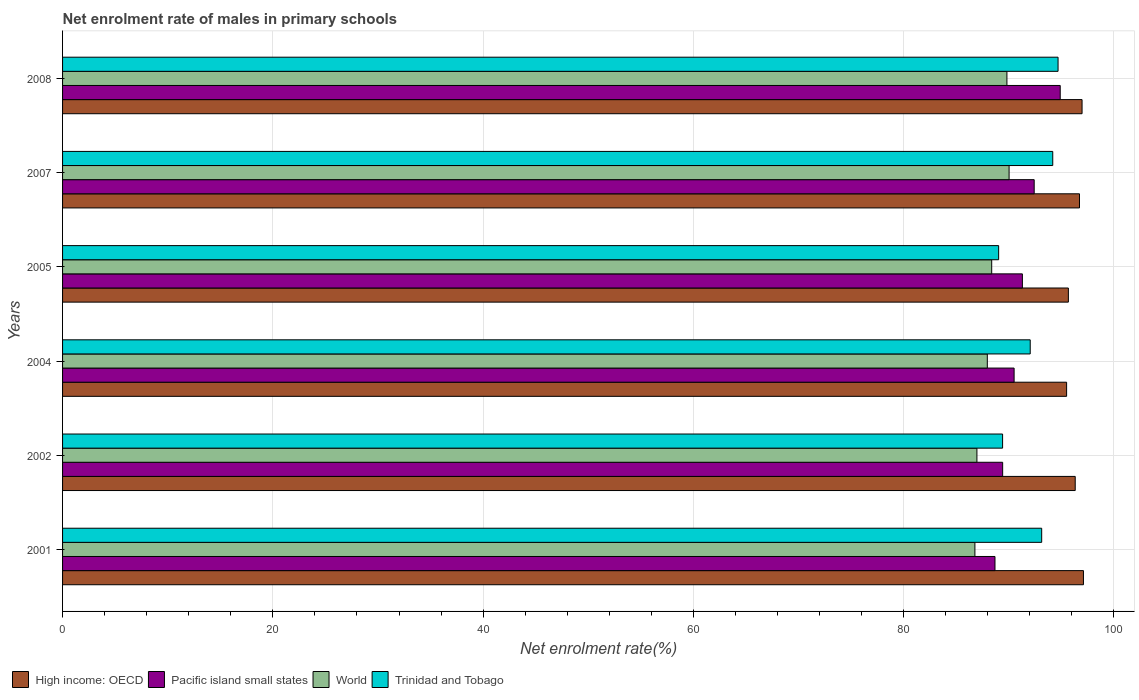Are the number of bars per tick equal to the number of legend labels?
Offer a terse response. Yes. Are the number of bars on each tick of the Y-axis equal?
Keep it short and to the point. Yes. How many bars are there on the 3rd tick from the top?
Offer a terse response. 4. How many bars are there on the 3rd tick from the bottom?
Provide a succinct answer. 4. In how many cases, is the number of bars for a given year not equal to the number of legend labels?
Your answer should be very brief. 0. What is the net enrolment rate of males in primary schools in High income: OECD in 2004?
Your response must be concise. 95.5. Across all years, what is the maximum net enrolment rate of males in primary schools in Pacific island small states?
Provide a short and direct response. 94.89. Across all years, what is the minimum net enrolment rate of males in primary schools in High income: OECD?
Provide a short and direct response. 95.5. In which year was the net enrolment rate of males in primary schools in High income: OECD maximum?
Keep it short and to the point. 2001. What is the total net enrolment rate of males in primary schools in High income: OECD in the graph?
Give a very brief answer. 578.27. What is the difference between the net enrolment rate of males in primary schools in Trinidad and Tobago in 2001 and that in 2004?
Offer a terse response. 1.09. What is the difference between the net enrolment rate of males in primary schools in Pacific island small states in 2008 and the net enrolment rate of males in primary schools in World in 2001?
Your answer should be compact. 8.11. What is the average net enrolment rate of males in primary schools in World per year?
Offer a very short reply. 88.32. In the year 2005, what is the difference between the net enrolment rate of males in primary schools in Trinidad and Tobago and net enrolment rate of males in primary schools in World?
Your response must be concise. 0.66. In how many years, is the net enrolment rate of males in primary schools in World greater than 96 %?
Your response must be concise. 0. What is the ratio of the net enrolment rate of males in primary schools in Pacific island small states in 2002 to that in 2007?
Provide a succinct answer. 0.97. Is the difference between the net enrolment rate of males in primary schools in Trinidad and Tobago in 2001 and 2004 greater than the difference between the net enrolment rate of males in primary schools in World in 2001 and 2004?
Provide a short and direct response. Yes. What is the difference between the highest and the second highest net enrolment rate of males in primary schools in High income: OECD?
Keep it short and to the point. 0.13. What is the difference between the highest and the lowest net enrolment rate of males in primary schools in World?
Provide a succinct answer. 3.25. Is the sum of the net enrolment rate of males in primary schools in Trinidad and Tobago in 2007 and 2008 greater than the maximum net enrolment rate of males in primary schools in High income: OECD across all years?
Offer a very short reply. Yes. Is it the case that in every year, the sum of the net enrolment rate of males in primary schools in Trinidad and Tobago and net enrolment rate of males in primary schools in Pacific island small states is greater than the sum of net enrolment rate of males in primary schools in High income: OECD and net enrolment rate of males in primary schools in World?
Offer a very short reply. Yes. What does the 1st bar from the top in 2007 represents?
Your response must be concise. Trinidad and Tobago. What does the 3rd bar from the bottom in 2004 represents?
Keep it short and to the point. World. Is it the case that in every year, the sum of the net enrolment rate of males in primary schools in World and net enrolment rate of males in primary schools in Trinidad and Tobago is greater than the net enrolment rate of males in primary schools in Pacific island small states?
Offer a terse response. Yes. How many bars are there?
Give a very brief answer. 24. Are all the bars in the graph horizontal?
Provide a short and direct response. Yes. How many years are there in the graph?
Your answer should be very brief. 6. Are the values on the major ticks of X-axis written in scientific E-notation?
Provide a succinct answer. No. Does the graph contain grids?
Your response must be concise. Yes. How are the legend labels stacked?
Provide a succinct answer. Horizontal. What is the title of the graph?
Ensure brevity in your answer.  Net enrolment rate of males in primary schools. Does "Malta" appear as one of the legend labels in the graph?
Give a very brief answer. No. What is the label or title of the X-axis?
Offer a very short reply. Net enrolment rate(%). What is the Net enrolment rate(%) of High income: OECD in 2001?
Offer a terse response. 97.1. What is the Net enrolment rate(%) in Pacific island small states in 2001?
Provide a short and direct response. 88.69. What is the Net enrolment rate(%) in World in 2001?
Your answer should be compact. 86.78. What is the Net enrolment rate(%) of Trinidad and Tobago in 2001?
Your answer should be compact. 93.13. What is the Net enrolment rate(%) of High income: OECD in 2002?
Offer a very short reply. 96.32. What is the Net enrolment rate(%) in Pacific island small states in 2002?
Your answer should be compact. 89.41. What is the Net enrolment rate(%) of World in 2002?
Your answer should be very brief. 86.97. What is the Net enrolment rate(%) in Trinidad and Tobago in 2002?
Ensure brevity in your answer.  89.41. What is the Net enrolment rate(%) in High income: OECD in 2004?
Your response must be concise. 95.5. What is the Net enrolment rate(%) of Pacific island small states in 2004?
Ensure brevity in your answer.  90.5. What is the Net enrolment rate(%) of World in 2004?
Provide a short and direct response. 87.96. What is the Net enrolment rate(%) of Trinidad and Tobago in 2004?
Ensure brevity in your answer.  92.04. What is the Net enrolment rate(%) in High income: OECD in 2005?
Give a very brief answer. 95.67. What is the Net enrolment rate(%) of Pacific island small states in 2005?
Your response must be concise. 91.29. What is the Net enrolment rate(%) in World in 2005?
Make the answer very short. 88.37. What is the Net enrolment rate(%) of Trinidad and Tobago in 2005?
Your answer should be very brief. 89.03. What is the Net enrolment rate(%) in High income: OECD in 2007?
Make the answer very short. 96.72. What is the Net enrolment rate(%) of Pacific island small states in 2007?
Keep it short and to the point. 92.42. What is the Net enrolment rate(%) of World in 2007?
Provide a succinct answer. 90.03. What is the Net enrolment rate(%) of Trinidad and Tobago in 2007?
Offer a terse response. 94.18. What is the Net enrolment rate(%) of High income: OECD in 2008?
Provide a short and direct response. 96.97. What is the Net enrolment rate(%) of Pacific island small states in 2008?
Your answer should be very brief. 94.89. What is the Net enrolment rate(%) in World in 2008?
Offer a terse response. 89.82. What is the Net enrolment rate(%) of Trinidad and Tobago in 2008?
Your answer should be compact. 94.68. Across all years, what is the maximum Net enrolment rate(%) of High income: OECD?
Make the answer very short. 97.1. Across all years, what is the maximum Net enrolment rate(%) in Pacific island small states?
Offer a very short reply. 94.89. Across all years, what is the maximum Net enrolment rate(%) in World?
Keep it short and to the point. 90.03. Across all years, what is the maximum Net enrolment rate(%) of Trinidad and Tobago?
Make the answer very short. 94.68. Across all years, what is the minimum Net enrolment rate(%) of High income: OECD?
Offer a terse response. 95.5. Across all years, what is the minimum Net enrolment rate(%) of Pacific island small states?
Offer a terse response. 88.69. Across all years, what is the minimum Net enrolment rate(%) in World?
Offer a terse response. 86.78. Across all years, what is the minimum Net enrolment rate(%) of Trinidad and Tobago?
Ensure brevity in your answer.  89.03. What is the total Net enrolment rate(%) in High income: OECD in the graph?
Your answer should be very brief. 578.27. What is the total Net enrolment rate(%) of Pacific island small states in the graph?
Keep it short and to the point. 547.2. What is the total Net enrolment rate(%) in World in the graph?
Your answer should be very brief. 529.92. What is the total Net enrolment rate(%) of Trinidad and Tobago in the graph?
Your response must be concise. 552.47. What is the difference between the Net enrolment rate(%) of High income: OECD in 2001 and that in 2002?
Make the answer very short. 0.78. What is the difference between the Net enrolment rate(%) in Pacific island small states in 2001 and that in 2002?
Provide a succinct answer. -0.73. What is the difference between the Net enrolment rate(%) in World in 2001 and that in 2002?
Provide a short and direct response. -0.19. What is the difference between the Net enrolment rate(%) in Trinidad and Tobago in 2001 and that in 2002?
Your answer should be compact. 3.72. What is the difference between the Net enrolment rate(%) of High income: OECD in 2001 and that in 2004?
Your answer should be very brief. 1.6. What is the difference between the Net enrolment rate(%) of Pacific island small states in 2001 and that in 2004?
Your response must be concise. -1.82. What is the difference between the Net enrolment rate(%) of World in 2001 and that in 2004?
Your answer should be compact. -1.18. What is the difference between the Net enrolment rate(%) in Trinidad and Tobago in 2001 and that in 2004?
Give a very brief answer. 1.09. What is the difference between the Net enrolment rate(%) in High income: OECD in 2001 and that in 2005?
Provide a short and direct response. 1.43. What is the difference between the Net enrolment rate(%) of Pacific island small states in 2001 and that in 2005?
Provide a short and direct response. -2.61. What is the difference between the Net enrolment rate(%) in World in 2001 and that in 2005?
Offer a terse response. -1.6. What is the difference between the Net enrolment rate(%) of Trinidad and Tobago in 2001 and that in 2005?
Your answer should be very brief. 4.09. What is the difference between the Net enrolment rate(%) in High income: OECD in 2001 and that in 2007?
Provide a short and direct response. 0.38. What is the difference between the Net enrolment rate(%) of Pacific island small states in 2001 and that in 2007?
Your answer should be very brief. -3.73. What is the difference between the Net enrolment rate(%) of World in 2001 and that in 2007?
Ensure brevity in your answer.  -3.25. What is the difference between the Net enrolment rate(%) in Trinidad and Tobago in 2001 and that in 2007?
Provide a succinct answer. -1.05. What is the difference between the Net enrolment rate(%) in High income: OECD in 2001 and that in 2008?
Your answer should be very brief. 0.13. What is the difference between the Net enrolment rate(%) in Pacific island small states in 2001 and that in 2008?
Your answer should be very brief. -6.2. What is the difference between the Net enrolment rate(%) in World in 2001 and that in 2008?
Offer a very short reply. -3.04. What is the difference between the Net enrolment rate(%) of Trinidad and Tobago in 2001 and that in 2008?
Your response must be concise. -1.56. What is the difference between the Net enrolment rate(%) of High income: OECD in 2002 and that in 2004?
Your answer should be very brief. 0.82. What is the difference between the Net enrolment rate(%) in Pacific island small states in 2002 and that in 2004?
Give a very brief answer. -1.09. What is the difference between the Net enrolment rate(%) in World in 2002 and that in 2004?
Provide a succinct answer. -0.99. What is the difference between the Net enrolment rate(%) of Trinidad and Tobago in 2002 and that in 2004?
Provide a short and direct response. -2.63. What is the difference between the Net enrolment rate(%) of High income: OECD in 2002 and that in 2005?
Provide a succinct answer. 0.65. What is the difference between the Net enrolment rate(%) of Pacific island small states in 2002 and that in 2005?
Offer a very short reply. -1.88. What is the difference between the Net enrolment rate(%) in World in 2002 and that in 2005?
Your answer should be very brief. -1.41. What is the difference between the Net enrolment rate(%) in Trinidad and Tobago in 2002 and that in 2005?
Your response must be concise. 0.38. What is the difference between the Net enrolment rate(%) in High income: OECD in 2002 and that in 2007?
Give a very brief answer. -0.41. What is the difference between the Net enrolment rate(%) in Pacific island small states in 2002 and that in 2007?
Keep it short and to the point. -3. What is the difference between the Net enrolment rate(%) of World in 2002 and that in 2007?
Keep it short and to the point. -3.06. What is the difference between the Net enrolment rate(%) of Trinidad and Tobago in 2002 and that in 2007?
Make the answer very short. -4.77. What is the difference between the Net enrolment rate(%) in High income: OECD in 2002 and that in 2008?
Ensure brevity in your answer.  -0.65. What is the difference between the Net enrolment rate(%) of Pacific island small states in 2002 and that in 2008?
Provide a succinct answer. -5.48. What is the difference between the Net enrolment rate(%) in World in 2002 and that in 2008?
Offer a terse response. -2.85. What is the difference between the Net enrolment rate(%) in Trinidad and Tobago in 2002 and that in 2008?
Ensure brevity in your answer.  -5.27. What is the difference between the Net enrolment rate(%) of High income: OECD in 2004 and that in 2005?
Provide a short and direct response. -0.17. What is the difference between the Net enrolment rate(%) in Pacific island small states in 2004 and that in 2005?
Make the answer very short. -0.79. What is the difference between the Net enrolment rate(%) in World in 2004 and that in 2005?
Offer a very short reply. -0.42. What is the difference between the Net enrolment rate(%) in Trinidad and Tobago in 2004 and that in 2005?
Make the answer very short. 3. What is the difference between the Net enrolment rate(%) of High income: OECD in 2004 and that in 2007?
Give a very brief answer. -1.22. What is the difference between the Net enrolment rate(%) in Pacific island small states in 2004 and that in 2007?
Your answer should be compact. -1.91. What is the difference between the Net enrolment rate(%) in World in 2004 and that in 2007?
Provide a short and direct response. -2.07. What is the difference between the Net enrolment rate(%) of Trinidad and Tobago in 2004 and that in 2007?
Offer a terse response. -2.14. What is the difference between the Net enrolment rate(%) in High income: OECD in 2004 and that in 2008?
Your response must be concise. -1.47. What is the difference between the Net enrolment rate(%) of Pacific island small states in 2004 and that in 2008?
Offer a very short reply. -4.39. What is the difference between the Net enrolment rate(%) in World in 2004 and that in 2008?
Ensure brevity in your answer.  -1.86. What is the difference between the Net enrolment rate(%) in Trinidad and Tobago in 2004 and that in 2008?
Provide a succinct answer. -2.65. What is the difference between the Net enrolment rate(%) of High income: OECD in 2005 and that in 2007?
Your answer should be very brief. -1.06. What is the difference between the Net enrolment rate(%) of Pacific island small states in 2005 and that in 2007?
Give a very brief answer. -1.12. What is the difference between the Net enrolment rate(%) in World in 2005 and that in 2007?
Make the answer very short. -1.65. What is the difference between the Net enrolment rate(%) in Trinidad and Tobago in 2005 and that in 2007?
Provide a succinct answer. -5.15. What is the difference between the Net enrolment rate(%) of High income: OECD in 2005 and that in 2008?
Give a very brief answer. -1.3. What is the difference between the Net enrolment rate(%) in Pacific island small states in 2005 and that in 2008?
Your answer should be very brief. -3.6. What is the difference between the Net enrolment rate(%) of World in 2005 and that in 2008?
Your response must be concise. -1.45. What is the difference between the Net enrolment rate(%) of Trinidad and Tobago in 2005 and that in 2008?
Your answer should be very brief. -5.65. What is the difference between the Net enrolment rate(%) in High income: OECD in 2007 and that in 2008?
Make the answer very short. -0.24. What is the difference between the Net enrolment rate(%) in Pacific island small states in 2007 and that in 2008?
Ensure brevity in your answer.  -2.48. What is the difference between the Net enrolment rate(%) in World in 2007 and that in 2008?
Keep it short and to the point. 0.21. What is the difference between the Net enrolment rate(%) in Trinidad and Tobago in 2007 and that in 2008?
Offer a very short reply. -0.51. What is the difference between the Net enrolment rate(%) of High income: OECD in 2001 and the Net enrolment rate(%) of Pacific island small states in 2002?
Provide a short and direct response. 7.68. What is the difference between the Net enrolment rate(%) in High income: OECD in 2001 and the Net enrolment rate(%) in World in 2002?
Ensure brevity in your answer.  10.13. What is the difference between the Net enrolment rate(%) of High income: OECD in 2001 and the Net enrolment rate(%) of Trinidad and Tobago in 2002?
Your answer should be very brief. 7.69. What is the difference between the Net enrolment rate(%) in Pacific island small states in 2001 and the Net enrolment rate(%) in World in 2002?
Give a very brief answer. 1.72. What is the difference between the Net enrolment rate(%) of Pacific island small states in 2001 and the Net enrolment rate(%) of Trinidad and Tobago in 2002?
Give a very brief answer. -0.72. What is the difference between the Net enrolment rate(%) of World in 2001 and the Net enrolment rate(%) of Trinidad and Tobago in 2002?
Your answer should be compact. -2.63. What is the difference between the Net enrolment rate(%) of High income: OECD in 2001 and the Net enrolment rate(%) of Pacific island small states in 2004?
Keep it short and to the point. 6.6. What is the difference between the Net enrolment rate(%) in High income: OECD in 2001 and the Net enrolment rate(%) in World in 2004?
Give a very brief answer. 9.14. What is the difference between the Net enrolment rate(%) of High income: OECD in 2001 and the Net enrolment rate(%) of Trinidad and Tobago in 2004?
Offer a terse response. 5.06. What is the difference between the Net enrolment rate(%) in Pacific island small states in 2001 and the Net enrolment rate(%) in World in 2004?
Your response must be concise. 0.73. What is the difference between the Net enrolment rate(%) of Pacific island small states in 2001 and the Net enrolment rate(%) of Trinidad and Tobago in 2004?
Your answer should be very brief. -3.35. What is the difference between the Net enrolment rate(%) in World in 2001 and the Net enrolment rate(%) in Trinidad and Tobago in 2004?
Give a very brief answer. -5.26. What is the difference between the Net enrolment rate(%) of High income: OECD in 2001 and the Net enrolment rate(%) of Pacific island small states in 2005?
Your answer should be compact. 5.81. What is the difference between the Net enrolment rate(%) in High income: OECD in 2001 and the Net enrolment rate(%) in World in 2005?
Provide a succinct answer. 8.73. What is the difference between the Net enrolment rate(%) in High income: OECD in 2001 and the Net enrolment rate(%) in Trinidad and Tobago in 2005?
Give a very brief answer. 8.07. What is the difference between the Net enrolment rate(%) in Pacific island small states in 2001 and the Net enrolment rate(%) in World in 2005?
Offer a very short reply. 0.31. What is the difference between the Net enrolment rate(%) in Pacific island small states in 2001 and the Net enrolment rate(%) in Trinidad and Tobago in 2005?
Offer a terse response. -0.35. What is the difference between the Net enrolment rate(%) of World in 2001 and the Net enrolment rate(%) of Trinidad and Tobago in 2005?
Offer a very short reply. -2.26. What is the difference between the Net enrolment rate(%) in High income: OECD in 2001 and the Net enrolment rate(%) in Pacific island small states in 2007?
Provide a succinct answer. 4.68. What is the difference between the Net enrolment rate(%) of High income: OECD in 2001 and the Net enrolment rate(%) of World in 2007?
Provide a short and direct response. 7.07. What is the difference between the Net enrolment rate(%) in High income: OECD in 2001 and the Net enrolment rate(%) in Trinidad and Tobago in 2007?
Provide a succinct answer. 2.92. What is the difference between the Net enrolment rate(%) of Pacific island small states in 2001 and the Net enrolment rate(%) of World in 2007?
Keep it short and to the point. -1.34. What is the difference between the Net enrolment rate(%) in Pacific island small states in 2001 and the Net enrolment rate(%) in Trinidad and Tobago in 2007?
Your response must be concise. -5.49. What is the difference between the Net enrolment rate(%) of World in 2001 and the Net enrolment rate(%) of Trinidad and Tobago in 2007?
Make the answer very short. -7.4. What is the difference between the Net enrolment rate(%) in High income: OECD in 2001 and the Net enrolment rate(%) in Pacific island small states in 2008?
Give a very brief answer. 2.21. What is the difference between the Net enrolment rate(%) of High income: OECD in 2001 and the Net enrolment rate(%) of World in 2008?
Make the answer very short. 7.28. What is the difference between the Net enrolment rate(%) of High income: OECD in 2001 and the Net enrolment rate(%) of Trinidad and Tobago in 2008?
Offer a terse response. 2.42. What is the difference between the Net enrolment rate(%) in Pacific island small states in 2001 and the Net enrolment rate(%) in World in 2008?
Offer a terse response. -1.13. What is the difference between the Net enrolment rate(%) in Pacific island small states in 2001 and the Net enrolment rate(%) in Trinidad and Tobago in 2008?
Keep it short and to the point. -6. What is the difference between the Net enrolment rate(%) of World in 2001 and the Net enrolment rate(%) of Trinidad and Tobago in 2008?
Your response must be concise. -7.91. What is the difference between the Net enrolment rate(%) in High income: OECD in 2002 and the Net enrolment rate(%) in Pacific island small states in 2004?
Offer a very short reply. 5.81. What is the difference between the Net enrolment rate(%) in High income: OECD in 2002 and the Net enrolment rate(%) in World in 2004?
Ensure brevity in your answer.  8.36. What is the difference between the Net enrolment rate(%) in High income: OECD in 2002 and the Net enrolment rate(%) in Trinidad and Tobago in 2004?
Give a very brief answer. 4.28. What is the difference between the Net enrolment rate(%) in Pacific island small states in 2002 and the Net enrolment rate(%) in World in 2004?
Your answer should be compact. 1.46. What is the difference between the Net enrolment rate(%) of Pacific island small states in 2002 and the Net enrolment rate(%) of Trinidad and Tobago in 2004?
Give a very brief answer. -2.62. What is the difference between the Net enrolment rate(%) in World in 2002 and the Net enrolment rate(%) in Trinidad and Tobago in 2004?
Ensure brevity in your answer.  -5.07. What is the difference between the Net enrolment rate(%) of High income: OECD in 2002 and the Net enrolment rate(%) of Pacific island small states in 2005?
Your answer should be very brief. 5.03. What is the difference between the Net enrolment rate(%) in High income: OECD in 2002 and the Net enrolment rate(%) in World in 2005?
Your response must be concise. 7.94. What is the difference between the Net enrolment rate(%) in High income: OECD in 2002 and the Net enrolment rate(%) in Trinidad and Tobago in 2005?
Provide a succinct answer. 7.28. What is the difference between the Net enrolment rate(%) of Pacific island small states in 2002 and the Net enrolment rate(%) of World in 2005?
Your answer should be very brief. 1.04. What is the difference between the Net enrolment rate(%) of Pacific island small states in 2002 and the Net enrolment rate(%) of Trinidad and Tobago in 2005?
Provide a succinct answer. 0.38. What is the difference between the Net enrolment rate(%) in World in 2002 and the Net enrolment rate(%) in Trinidad and Tobago in 2005?
Make the answer very short. -2.07. What is the difference between the Net enrolment rate(%) in High income: OECD in 2002 and the Net enrolment rate(%) in Pacific island small states in 2007?
Your answer should be compact. 3.9. What is the difference between the Net enrolment rate(%) of High income: OECD in 2002 and the Net enrolment rate(%) of World in 2007?
Your response must be concise. 6.29. What is the difference between the Net enrolment rate(%) in High income: OECD in 2002 and the Net enrolment rate(%) in Trinidad and Tobago in 2007?
Ensure brevity in your answer.  2.14. What is the difference between the Net enrolment rate(%) of Pacific island small states in 2002 and the Net enrolment rate(%) of World in 2007?
Provide a succinct answer. -0.61. What is the difference between the Net enrolment rate(%) of Pacific island small states in 2002 and the Net enrolment rate(%) of Trinidad and Tobago in 2007?
Your answer should be compact. -4.76. What is the difference between the Net enrolment rate(%) in World in 2002 and the Net enrolment rate(%) in Trinidad and Tobago in 2007?
Your answer should be compact. -7.21. What is the difference between the Net enrolment rate(%) in High income: OECD in 2002 and the Net enrolment rate(%) in Pacific island small states in 2008?
Provide a short and direct response. 1.43. What is the difference between the Net enrolment rate(%) of High income: OECD in 2002 and the Net enrolment rate(%) of World in 2008?
Give a very brief answer. 6.5. What is the difference between the Net enrolment rate(%) in High income: OECD in 2002 and the Net enrolment rate(%) in Trinidad and Tobago in 2008?
Offer a very short reply. 1.63. What is the difference between the Net enrolment rate(%) in Pacific island small states in 2002 and the Net enrolment rate(%) in World in 2008?
Provide a succinct answer. -0.41. What is the difference between the Net enrolment rate(%) of Pacific island small states in 2002 and the Net enrolment rate(%) of Trinidad and Tobago in 2008?
Your answer should be very brief. -5.27. What is the difference between the Net enrolment rate(%) in World in 2002 and the Net enrolment rate(%) in Trinidad and Tobago in 2008?
Make the answer very short. -7.72. What is the difference between the Net enrolment rate(%) of High income: OECD in 2004 and the Net enrolment rate(%) of Pacific island small states in 2005?
Provide a short and direct response. 4.21. What is the difference between the Net enrolment rate(%) of High income: OECD in 2004 and the Net enrolment rate(%) of World in 2005?
Make the answer very short. 7.12. What is the difference between the Net enrolment rate(%) in High income: OECD in 2004 and the Net enrolment rate(%) in Trinidad and Tobago in 2005?
Keep it short and to the point. 6.47. What is the difference between the Net enrolment rate(%) in Pacific island small states in 2004 and the Net enrolment rate(%) in World in 2005?
Your answer should be very brief. 2.13. What is the difference between the Net enrolment rate(%) of Pacific island small states in 2004 and the Net enrolment rate(%) of Trinidad and Tobago in 2005?
Provide a succinct answer. 1.47. What is the difference between the Net enrolment rate(%) in World in 2004 and the Net enrolment rate(%) in Trinidad and Tobago in 2005?
Offer a very short reply. -1.08. What is the difference between the Net enrolment rate(%) in High income: OECD in 2004 and the Net enrolment rate(%) in Pacific island small states in 2007?
Give a very brief answer. 3.08. What is the difference between the Net enrolment rate(%) of High income: OECD in 2004 and the Net enrolment rate(%) of World in 2007?
Offer a very short reply. 5.47. What is the difference between the Net enrolment rate(%) of High income: OECD in 2004 and the Net enrolment rate(%) of Trinidad and Tobago in 2007?
Your response must be concise. 1.32. What is the difference between the Net enrolment rate(%) of Pacific island small states in 2004 and the Net enrolment rate(%) of World in 2007?
Your answer should be compact. 0.48. What is the difference between the Net enrolment rate(%) of Pacific island small states in 2004 and the Net enrolment rate(%) of Trinidad and Tobago in 2007?
Ensure brevity in your answer.  -3.68. What is the difference between the Net enrolment rate(%) of World in 2004 and the Net enrolment rate(%) of Trinidad and Tobago in 2007?
Give a very brief answer. -6.22. What is the difference between the Net enrolment rate(%) in High income: OECD in 2004 and the Net enrolment rate(%) in Pacific island small states in 2008?
Ensure brevity in your answer.  0.61. What is the difference between the Net enrolment rate(%) of High income: OECD in 2004 and the Net enrolment rate(%) of World in 2008?
Offer a very short reply. 5.68. What is the difference between the Net enrolment rate(%) of High income: OECD in 2004 and the Net enrolment rate(%) of Trinidad and Tobago in 2008?
Offer a terse response. 0.81. What is the difference between the Net enrolment rate(%) in Pacific island small states in 2004 and the Net enrolment rate(%) in World in 2008?
Your response must be concise. 0.68. What is the difference between the Net enrolment rate(%) of Pacific island small states in 2004 and the Net enrolment rate(%) of Trinidad and Tobago in 2008?
Ensure brevity in your answer.  -4.18. What is the difference between the Net enrolment rate(%) in World in 2004 and the Net enrolment rate(%) in Trinidad and Tobago in 2008?
Make the answer very short. -6.73. What is the difference between the Net enrolment rate(%) of High income: OECD in 2005 and the Net enrolment rate(%) of Pacific island small states in 2007?
Your response must be concise. 3.25. What is the difference between the Net enrolment rate(%) in High income: OECD in 2005 and the Net enrolment rate(%) in World in 2007?
Your answer should be compact. 5.64. What is the difference between the Net enrolment rate(%) of High income: OECD in 2005 and the Net enrolment rate(%) of Trinidad and Tobago in 2007?
Make the answer very short. 1.49. What is the difference between the Net enrolment rate(%) of Pacific island small states in 2005 and the Net enrolment rate(%) of World in 2007?
Provide a succinct answer. 1.26. What is the difference between the Net enrolment rate(%) in Pacific island small states in 2005 and the Net enrolment rate(%) in Trinidad and Tobago in 2007?
Provide a succinct answer. -2.89. What is the difference between the Net enrolment rate(%) in World in 2005 and the Net enrolment rate(%) in Trinidad and Tobago in 2007?
Your answer should be very brief. -5.81. What is the difference between the Net enrolment rate(%) in High income: OECD in 2005 and the Net enrolment rate(%) in Pacific island small states in 2008?
Ensure brevity in your answer.  0.78. What is the difference between the Net enrolment rate(%) of High income: OECD in 2005 and the Net enrolment rate(%) of World in 2008?
Offer a very short reply. 5.85. What is the difference between the Net enrolment rate(%) of High income: OECD in 2005 and the Net enrolment rate(%) of Trinidad and Tobago in 2008?
Offer a very short reply. 0.98. What is the difference between the Net enrolment rate(%) in Pacific island small states in 2005 and the Net enrolment rate(%) in World in 2008?
Your answer should be compact. 1.47. What is the difference between the Net enrolment rate(%) of Pacific island small states in 2005 and the Net enrolment rate(%) of Trinidad and Tobago in 2008?
Your response must be concise. -3.39. What is the difference between the Net enrolment rate(%) in World in 2005 and the Net enrolment rate(%) in Trinidad and Tobago in 2008?
Provide a succinct answer. -6.31. What is the difference between the Net enrolment rate(%) in High income: OECD in 2007 and the Net enrolment rate(%) in Pacific island small states in 2008?
Make the answer very short. 1.83. What is the difference between the Net enrolment rate(%) of High income: OECD in 2007 and the Net enrolment rate(%) of World in 2008?
Give a very brief answer. 6.9. What is the difference between the Net enrolment rate(%) in High income: OECD in 2007 and the Net enrolment rate(%) in Trinidad and Tobago in 2008?
Ensure brevity in your answer.  2.04. What is the difference between the Net enrolment rate(%) of Pacific island small states in 2007 and the Net enrolment rate(%) of World in 2008?
Ensure brevity in your answer.  2.59. What is the difference between the Net enrolment rate(%) of Pacific island small states in 2007 and the Net enrolment rate(%) of Trinidad and Tobago in 2008?
Give a very brief answer. -2.27. What is the difference between the Net enrolment rate(%) in World in 2007 and the Net enrolment rate(%) in Trinidad and Tobago in 2008?
Offer a very short reply. -4.66. What is the average Net enrolment rate(%) of High income: OECD per year?
Give a very brief answer. 96.38. What is the average Net enrolment rate(%) in Pacific island small states per year?
Provide a short and direct response. 91.2. What is the average Net enrolment rate(%) in World per year?
Keep it short and to the point. 88.32. What is the average Net enrolment rate(%) in Trinidad and Tobago per year?
Offer a terse response. 92.08. In the year 2001, what is the difference between the Net enrolment rate(%) of High income: OECD and Net enrolment rate(%) of Pacific island small states?
Make the answer very short. 8.41. In the year 2001, what is the difference between the Net enrolment rate(%) in High income: OECD and Net enrolment rate(%) in World?
Provide a short and direct response. 10.32. In the year 2001, what is the difference between the Net enrolment rate(%) of High income: OECD and Net enrolment rate(%) of Trinidad and Tobago?
Keep it short and to the point. 3.97. In the year 2001, what is the difference between the Net enrolment rate(%) in Pacific island small states and Net enrolment rate(%) in World?
Your answer should be compact. 1.91. In the year 2001, what is the difference between the Net enrolment rate(%) of Pacific island small states and Net enrolment rate(%) of Trinidad and Tobago?
Offer a very short reply. -4.44. In the year 2001, what is the difference between the Net enrolment rate(%) in World and Net enrolment rate(%) in Trinidad and Tobago?
Provide a short and direct response. -6.35. In the year 2002, what is the difference between the Net enrolment rate(%) of High income: OECD and Net enrolment rate(%) of Pacific island small states?
Provide a succinct answer. 6.9. In the year 2002, what is the difference between the Net enrolment rate(%) in High income: OECD and Net enrolment rate(%) in World?
Make the answer very short. 9.35. In the year 2002, what is the difference between the Net enrolment rate(%) of High income: OECD and Net enrolment rate(%) of Trinidad and Tobago?
Ensure brevity in your answer.  6.91. In the year 2002, what is the difference between the Net enrolment rate(%) in Pacific island small states and Net enrolment rate(%) in World?
Your answer should be compact. 2.45. In the year 2002, what is the difference between the Net enrolment rate(%) in Pacific island small states and Net enrolment rate(%) in Trinidad and Tobago?
Give a very brief answer. 0. In the year 2002, what is the difference between the Net enrolment rate(%) in World and Net enrolment rate(%) in Trinidad and Tobago?
Your answer should be compact. -2.44. In the year 2004, what is the difference between the Net enrolment rate(%) in High income: OECD and Net enrolment rate(%) in Pacific island small states?
Your answer should be compact. 4.99. In the year 2004, what is the difference between the Net enrolment rate(%) in High income: OECD and Net enrolment rate(%) in World?
Keep it short and to the point. 7.54. In the year 2004, what is the difference between the Net enrolment rate(%) in High income: OECD and Net enrolment rate(%) in Trinidad and Tobago?
Your answer should be compact. 3.46. In the year 2004, what is the difference between the Net enrolment rate(%) of Pacific island small states and Net enrolment rate(%) of World?
Your answer should be compact. 2.55. In the year 2004, what is the difference between the Net enrolment rate(%) in Pacific island small states and Net enrolment rate(%) in Trinidad and Tobago?
Offer a very short reply. -1.53. In the year 2004, what is the difference between the Net enrolment rate(%) in World and Net enrolment rate(%) in Trinidad and Tobago?
Offer a terse response. -4.08. In the year 2005, what is the difference between the Net enrolment rate(%) in High income: OECD and Net enrolment rate(%) in Pacific island small states?
Give a very brief answer. 4.37. In the year 2005, what is the difference between the Net enrolment rate(%) in High income: OECD and Net enrolment rate(%) in World?
Provide a succinct answer. 7.29. In the year 2005, what is the difference between the Net enrolment rate(%) in High income: OECD and Net enrolment rate(%) in Trinidad and Tobago?
Keep it short and to the point. 6.63. In the year 2005, what is the difference between the Net enrolment rate(%) in Pacific island small states and Net enrolment rate(%) in World?
Offer a terse response. 2.92. In the year 2005, what is the difference between the Net enrolment rate(%) in Pacific island small states and Net enrolment rate(%) in Trinidad and Tobago?
Provide a succinct answer. 2.26. In the year 2005, what is the difference between the Net enrolment rate(%) in World and Net enrolment rate(%) in Trinidad and Tobago?
Ensure brevity in your answer.  -0.66. In the year 2007, what is the difference between the Net enrolment rate(%) in High income: OECD and Net enrolment rate(%) in Pacific island small states?
Provide a succinct answer. 4.31. In the year 2007, what is the difference between the Net enrolment rate(%) of High income: OECD and Net enrolment rate(%) of World?
Provide a short and direct response. 6.7. In the year 2007, what is the difference between the Net enrolment rate(%) of High income: OECD and Net enrolment rate(%) of Trinidad and Tobago?
Provide a succinct answer. 2.54. In the year 2007, what is the difference between the Net enrolment rate(%) of Pacific island small states and Net enrolment rate(%) of World?
Provide a succinct answer. 2.39. In the year 2007, what is the difference between the Net enrolment rate(%) of Pacific island small states and Net enrolment rate(%) of Trinidad and Tobago?
Keep it short and to the point. -1.76. In the year 2007, what is the difference between the Net enrolment rate(%) of World and Net enrolment rate(%) of Trinidad and Tobago?
Give a very brief answer. -4.15. In the year 2008, what is the difference between the Net enrolment rate(%) in High income: OECD and Net enrolment rate(%) in Pacific island small states?
Keep it short and to the point. 2.08. In the year 2008, what is the difference between the Net enrolment rate(%) in High income: OECD and Net enrolment rate(%) in World?
Your answer should be very brief. 7.15. In the year 2008, what is the difference between the Net enrolment rate(%) in High income: OECD and Net enrolment rate(%) in Trinidad and Tobago?
Your answer should be compact. 2.28. In the year 2008, what is the difference between the Net enrolment rate(%) of Pacific island small states and Net enrolment rate(%) of World?
Give a very brief answer. 5.07. In the year 2008, what is the difference between the Net enrolment rate(%) of Pacific island small states and Net enrolment rate(%) of Trinidad and Tobago?
Provide a short and direct response. 0.21. In the year 2008, what is the difference between the Net enrolment rate(%) of World and Net enrolment rate(%) of Trinidad and Tobago?
Your answer should be very brief. -4.86. What is the ratio of the Net enrolment rate(%) of World in 2001 to that in 2002?
Offer a terse response. 1. What is the ratio of the Net enrolment rate(%) of Trinidad and Tobago in 2001 to that in 2002?
Offer a very short reply. 1.04. What is the ratio of the Net enrolment rate(%) in High income: OECD in 2001 to that in 2004?
Your answer should be compact. 1.02. What is the ratio of the Net enrolment rate(%) in Pacific island small states in 2001 to that in 2004?
Ensure brevity in your answer.  0.98. What is the ratio of the Net enrolment rate(%) in World in 2001 to that in 2004?
Provide a succinct answer. 0.99. What is the ratio of the Net enrolment rate(%) in Trinidad and Tobago in 2001 to that in 2004?
Your response must be concise. 1.01. What is the ratio of the Net enrolment rate(%) of High income: OECD in 2001 to that in 2005?
Your response must be concise. 1.01. What is the ratio of the Net enrolment rate(%) of Pacific island small states in 2001 to that in 2005?
Make the answer very short. 0.97. What is the ratio of the Net enrolment rate(%) of World in 2001 to that in 2005?
Keep it short and to the point. 0.98. What is the ratio of the Net enrolment rate(%) in Trinidad and Tobago in 2001 to that in 2005?
Your response must be concise. 1.05. What is the ratio of the Net enrolment rate(%) in Pacific island small states in 2001 to that in 2007?
Give a very brief answer. 0.96. What is the ratio of the Net enrolment rate(%) in World in 2001 to that in 2007?
Your response must be concise. 0.96. What is the ratio of the Net enrolment rate(%) of Trinidad and Tobago in 2001 to that in 2007?
Offer a terse response. 0.99. What is the ratio of the Net enrolment rate(%) of High income: OECD in 2001 to that in 2008?
Provide a short and direct response. 1. What is the ratio of the Net enrolment rate(%) of Pacific island small states in 2001 to that in 2008?
Keep it short and to the point. 0.93. What is the ratio of the Net enrolment rate(%) in World in 2001 to that in 2008?
Keep it short and to the point. 0.97. What is the ratio of the Net enrolment rate(%) in Trinidad and Tobago in 2001 to that in 2008?
Make the answer very short. 0.98. What is the ratio of the Net enrolment rate(%) in High income: OECD in 2002 to that in 2004?
Ensure brevity in your answer.  1.01. What is the ratio of the Net enrolment rate(%) of World in 2002 to that in 2004?
Your response must be concise. 0.99. What is the ratio of the Net enrolment rate(%) of Trinidad and Tobago in 2002 to that in 2004?
Give a very brief answer. 0.97. What is the ratio of the Net enrolment rate(%) in High income: OECD in 2002 to that in 2005?
Offer a terse response. 1.01. What is the ratio of the Net enrolment rate(%) of Pacific island small states in 2002 to that in 2005?
Your answer should be very brief. 0.98. What is the ratio of the Net enrolment rate(%) in World in 2002 to that in 2005?
Offer a very short reply. 0.98. What is the ratio of the Net enrolment rate(%) of Trinidad and Tobago in 2002 to that in 2005?
Ensure brevity in your answer.  1. What is the ratio of the Net enrolment rate(%) in High income: OECD in 2002 to that in 2007?
Offer a terse response. 1. What is the ratio of the Net enrolment rate(%) of Pacific island small states in 2002 to that in 2007?
Your response must be concise. 0.97. What is the ratio of the Net enrolment rate(%) in Trinidad and Tobago in 2002 to that in 2007?
Make the answer very short. 0.95. What is the ratio of the Net enrolment rate(%) of Pacific island small states in 2002 to that in 2008?
Provide a short and direct response. 0.94. What is the ratio of the Net enrolment rate(%) of World in 2002 to that in 2008?
Give a very brief answer. 0.97. What is the ratio of the Net enrolment rate(%) in Trinidad and Tobago in 2002 to that in 2008?
Provide a succinct answer. 0.94. What is the ratio of the Net enrolment rate(%) in Pacific island small states in 2004 to that in 2005?
Ensure brevity in your answer.  0.99. What is the ratio of the Net enrolment rate(%) in World in 2004 to that in 2005?
Offer a very short reply. 1. What is the ratio of the Net enrolment rate(%) in Trinidad and Tobago in 2004 to that in 2005?
Offer a very short reply. 1.03. What is the ratio of the Net enrolment rate(%) of High income: OECD in 2004 to that in 2007?
Offer a terse response. 0.99. What is the ratio of the Net enrolment rate(%) in Pacific island small states in 2004 to that in 2007?
Your answer should be very brief. 0.98. What is the ratio of the Net enrolment rate(%) in Trinidad and Tobago in 2004 to that in 2007?
Provide a succinct answer. 0.98. What is the ratio of the Net enrolment rate(%) in High income: OECD in 2004 to that in 2008?
Your answer should be very brief. 0.98. What is the ratio of the Net enrolment rate(%) in Pacific island small states in 2004 to that in 2008?
Provide a succinct answer. 0.95. What is the ratio of the Net enrolment rate(%) of World in 2004 to that in 2008?
Keep it short and to the point. 0.98. What is the ratio of the Net enrolment rate(%) in Trinidad and Tobago in 2004 to that in 2008?
Your answer should be compact. 0.97. What is the ratio of the Net enrolment rate(%) in Pacific island small states in 2005 to that in 2007?
Give a very brief answer. 0.99. What is the ratio of the Net enrolment rate(%) of World in 2005 to that in 2007?
Give a very brief answer. 0.98. What is the ratio of the Net enrolment rate(%) of Trinidad and Tobago in 2005 to that in 2007?
Your answer should be very brief. 0.95. What is the ratio of the Net enrolment rate(%) in High income: OECD in 2005 to that in 2008?
Make the answer very short. 0.99. What is the ratio of the Net enrolment rate(%) in Pacific island small states in 2005 to that in 2008?
Keep it short and to the point. 0.96. What is the ratio of the Net enrolment rate(%) of World in 2005 to that in 2008?
Make the answer very short. 0.98. What is the ratio of the Net enrolment rate(%) of Trinidad and Tobago in 2005 to that in 2008?
Provide a succinct answer. 0.94. What is the ratio of the Net enrolment rate(%) of Pacific island small states in 2007 to that in 2008?
Keep it short and to the point. 0.97. What is the difference between the highest and the second highest Net enrolment rate(%) of High income: OECD?
Give a very brief answer. 0.13. What is the difference between the highest and the second highest Net enrolment rate(%) of Pacific island small states?
Your answer should be compact. 2.48. What is the difference between the highest and the second highest Net enrolment rate(%) of World?
Keep it short and to the point. 0.21. What is the difference between the highest and the second highest Net enrolment rate(%) in Trinidad and Tobago?
Keep it short and to the point. 0.51. What is the difference between the highest and the lowest Net enrolment rate(%) in High income: OECD?
Keep it short and to the point. 1.6. What is the difference between the highest and the lowest Net enrolment rate(%) in Pacific island small states?
Ensure brevity in your answer.  6.2. What is the difference between the highest and the lowest Net enrolment rate(%) in World?
Your answer should be compact. 3.25. What is the difference between the highest and the lowest Net enrolment rate(%) of Trinidad and Tobago?
Your response must be concise. 5.65. 